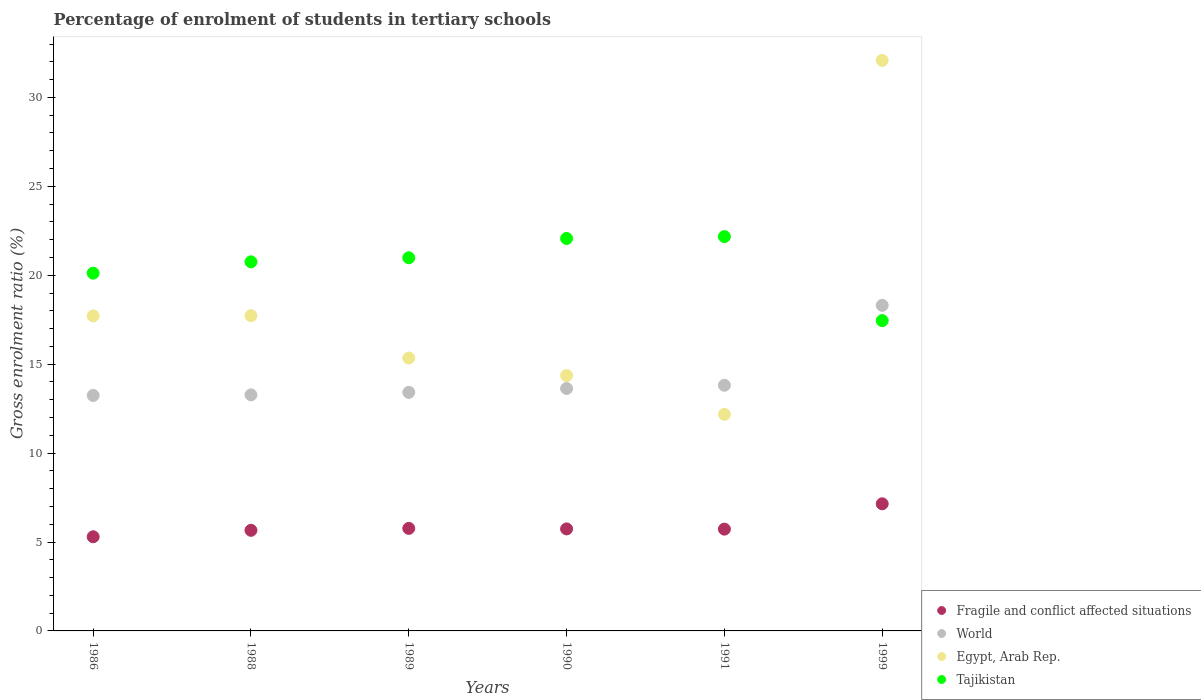How many different coloured dotlines are there?
Your answer should be very brief. 4. What is the percentage of students enrolled in tertiary schools in Tajikistan in 1999?
Your answer should be compact. 17.45. Across all years, what is the maximum percentage of students enrolled in tertiary schools in World?
Your answer should be compact. 18.31. Across all years, what is the minimum percentage of students enrolled in tertiary schools in Egypt, Arab Rep.?
Provide a short and direct response. 12.18. In which year was the percentage of students enrolled in tertiary schools in Tajikistan minimum?
Provide a succinct answer. 1999. What is the total percentage of students enrolled in tertiary schools in Fragile and conflict affected situations in the graph?
Your answer should be very brief. 35.33. What is the difference between the percentage of students enrolled in tertiary schools in Fragile and conflict affected situations in 1989 and that in 1999?
Your answer should be compact. -1.38. What is the difference between the percentage of students enrolled in tertiary schools in Fragile and conflict affected situations in 1988 and the percentage of students enrolled in tertiary schools in Tajikistan in 1999?
Provide a succinct answer. -11.79. What is the average percentage of students enrolled in tertiary schools in Fragile and conflict affected situations per year?
Offer a very short reply. 5.89. In the year 1986, what is the difference between the percentage of students enrolled in tertiary schools in World and percentage of students enrolled in tertiary schools in Egypt, Arab Rep.?
Give a very brief answer. -4.48. What is the ratio of the percentage of students enrolled in tertiary schools in Fragile and conflict affected situations in 1988 to that in 1999?
Keep it short and to the point. 0.79. What is the difference between the highest and the second highest percentage of students enrolled in tertiary schools in Tajikistan?
Provide a succinct answer. 0.11. What is the difference between the highest and the lowest percentage of students enrolled in tertiary schools in Egypt, Arab Rep.?
Make the answer very short. 19.9. In how many years, is the percentage of students enrolled in tertiary schools in Egypt, Arab Rep. greater than the average percentage of students enrolled in tertiary schools in Egypt, Arab Rep. taken over all years?
Your answer should be compact. 1. Is it the case that in every year, the sum of the percentage of students enrolled in tertiary schools in Egypt, Arab Rep. and percentage of students enrolled in tertiary schools in Tajikistan  is greater than the sum of percentage of students enrolled in tertiary schools in World and percentage of students enrolled in tertiary schools in Fragile and conflict affected situations?
Your response must be concise. No. What is the title of the graph?
Provide a short and direct response. Percentage of enrolment of students in tertiary schools. Does "United Arab Emirates" appear as one of the legend labels in the graph?
Give a very brief answer. No. What is the label or title of the X-axis?
Ensure brevity in your answer.  Years. What is the Gross enrolment ratio (%) in Fragile and conflict affected situations in 1986?
Offer a very short reply. 5.29. What is the Gross enrolment ratio (%) of World in 1986?
Provide a short and direct response. 13.24. What is the Gross enrolment ratio (%) of Egypt, Arab Rep. in 1986?
Offer a very short reply. 17.72. What is the Gross enrolment ratio (%) of Tajikistan in 1986?
Provide a succinct answer. 20.12. What is the Gross enrolment ratio (%) in Fragile and conflict affected situations in 1988?
Keep it short and to the point. 5.66. What is the Gross enrolment ratio (%) in World in 1988?
Provide a short and direct response. 13.27. What is the Gross enrolment ratio (%) of Egypt, Arab Rep. in 1988?
Give a very brief answer. 17.73. What is the Gross enrolment ratio (%) of Tajikistan in 1988?
Make the answer very short. 20.75. What is the Gross enrolment ratio (%) in Fragile and conflict affected situations in 1989?
Offer a very short reply. 5.77. What is the Gross enrolment ratio (%) of World in 1989?
Offer a terse response. 13.41. What is the Gross enrolment ratio (%) of Egypt, Arab Rep. in 1989?
Offer a terse response. 15.34. What is the Gross enrolment ratio (%) in Tajikistan in 1989?
Offer a very short reply. 20.98. What is the Gross enrolment ratio (%) in Fragile and conflict affected situations in 1990?
Your answer should be compact. 5.74. What is the Gross enrolment ratio (%) in World in 1990?
Ensure brevity in your answer.  13.63. What is the Gross enrolment ratio (%) of Egypt, Arab Rep. in 1990?
Provide a succinct answer. 14.36. What is the Gross enrolment ratio (%) of Tajikistan in 1990?
Give a very brief answer. 22.07. What is the Gross enrolment ratio (%) of Fragile and conflict affected situations in 1991?
Provide a succinct answer. 5.72. What is the Gross enrolment ratio (%) in World in 1991?
Your answer should be very brief. 13.81. What is the Gross enrolment ratio (%) in Egypt, Arab Rep. in 1991?
Make the answer very short. 12.18. What is the Gross enrolment ratio (%) of Tajikistan in 1991?
Your answer should be compact. 22.17. What is the Gross enrolment ratio (%) in Fragile and conflict affected situations in 1999?
Your answer should be compact. 7.15. What is the Gross enrolment ratio (%) of World in 1999?
Give a very brief answer. 18.31. What is the Gross enrolment ratio (%) of Egypt, Arab Rep. in 1999?
Make the answer very short. 32.08. What is the Gross enrolment ratio (%) of Tajikistan in 1999?
Offer a terse response. 17.45. Across all years, what is the maximum Gross enrolment ratio (%) in Fragile and conflict affected situations?
Offer a very short reply. 7.15. Across all years, what is the maximum Gross enrolment ratio (%) in World?
Provide a short and direct response. 18.31. Across all years, what is the maximum Gross enrolment ratio (%) in Egypt, Arab Rep.?
Make the answer very short. 32.08. Across all years, what is the maximum Gross enrolment ratio (%) in Tajikistan?
Your response must be concise. 22.17. Across all years, what is the minimum Gross enrolment ratio (%) in Fragile and conflict affected situations?
Your answer should be very brief. 5.29. Across all years, what is the minimum Gross enrolment ratio (%) in World?
Keep it short and to the point. 13.24. Across all years, what is the minimum Gross enrolment ratio (%) of Egypt, Arab Rep.?
Make the answer very short. 12.18. Across all years, what is the minimum Gross enrolment ratio (%) of Tajikistan?
Your answer should be compact. 17.45. What is the total Gross enrolment ratio (%) in Fragile and conflict affected situations in the graph?
Provide a short and direct response. 35.33. What is the total Gross enrolment ratio (%) in World in the graph?
Your answer should be compact. 85.68. What is the total Gross enrolment ratio (%) of Egypt, Arab Rep. in the graph?
Ensure brevity in your answer.  109.4. What is the total Gross enrolment ratio (%) in Tajikistan in the graph?
Offer a terse response. 123.54. What is the difference between the Gross enrolment ratio (%) in Fragile and conflict affected situations in 1986 and that in 1988?
Provide a succinct answer. -0.36. What is the difference between the Gross enrolment ratio (%) in World in 1986 and that in 1988?
Provide a short and direct response. -0.03. What is the difference between the Gross enrolment ratio (%) in Egypt, Arab Rep. in 1986 and that in 1988?
Your response must be concise. -0.01. What is the difference between the Gross enrolment ratio (%) in Tajikistan in 1986 and that in 1988?
Provide a succinct answer. -0.64. What is the difference between the Gross enrolment ratio (%) in Fragile and conflict affected situations in 1986 and that in 1989?
Make the answer very short. -0.47. What is the difference between the Gross enrolment ratio (%) of World in 1986 and that in 1989?
Your answer should be compact. -0.17. What is the difference between the Gross enrolment ratio (%) in Egypt, Arab Rep. in 1986 and that in 1989?
Provide a short and direct response. 2.37. What is the difference between the Gross enrolment ratio (%) of Tajikistan in 1986 and that in 1989?
Your response must be concise. -0.87. What is the difference between the Gross enrolment ratio (%) of Fragile and conflict affected situations in 1986 and that in 1990?
Give a very brief answer. -0.44. What is the difference between the Gross enrolment ratio (%) in World in 1986 and that in 1990?
Make the answer very short. -0.39. What is the difference between the Gross enrolment ratio (%) of Egypt, Arab Rep. in 1986 and that in 1990?
Provide a succinct answer. 3.36. What is the difference between the Gross enrolment ratio (%) of Tajikistan in 1986 and that in 1990?
Offer a terse response. -1.95. What is the difference between the Gross enrolment ratio (%) in Fragile and conflict affected situations in 1986 and that in 1991?
Keep it short and to the point. -0.43. What is the difference between the Gross enrolment ratio (%) of World in 1986 and that in 1991?
Ensure brevity in your answer.  -0.57. What is the difference between the Gross enrolment ratio (%) of Egypt, Arab Rep. in 1986 and that in 1991?
Your answer should be very brief. 5.54. What is the difference between the Gross enrolment ratio (%) in Tajikistan in 1986 and that in 1991?
Provide a succinct answer. -2.05. What is the difference between the Gross enrolment ratio (%) of Fragile and conflict affected situations in 1986 and that in 1999?
Provide a succinct answer. -1.85. What is the difference between the Gross enrolment ratio (%) of World in 1986 and that in 1999?
Keep it short and to the point. -5.07. What is the difference between the Gross enrolment ratio (%) in Egypt, Arab Rep. in 1986 and that in 1999?
Offer a very short reply. -14.37. What is the difference between the Gross enrolment ratio (%) of Tajikistan in 1986 and that in 1999?
Make the answer very short. 2.67. What is the difference between the Gross enrolment ratio (%) in Fragile and conflict affected situations in 1988 and that in 1989?
Offer a very short reply. -0.11. What is the difference between the Gross enrolment ratio (%) of World in 1988 and that in 1989?
Offer a very short reply. -0.14. What is the difference between the Gross enrolment ratio (%) in Egypt, Arab Rep. in 1988 and that in 1989?
Offer a very short reply. 2.38. What is the difference between the Gross enrolment ratio (%) of Tajikistan in 1988 and that in 1989?
Provide a short and direct response. -0.23. What is the difference between the Gross enrolment ratio (%) in Fragile and conflict affected situations in 1988 and that in 1990?
Give a very brief answer. -0.08. What is the difference between the Gross enrolment ratio (%) of World in 1988 and that in 1990?
Your response must be concise. -0.36. What is the difference between the Gross enrolment ratio (%) in Egypt, Arab Rep. in 1988 and that in 1990?
Ensure brevity in your answer.  3.37. What is the difference between the Gross enrolment ratio (%) of Tajikistan in 1988 and that in 1990?
Ensure brevity in your answer.  -1.31. What is the difference between the Gross enrolment ratio (%) of Fragile and conflict affected situations in 1988 and that in 1991?
Your answer should be very brief. -0.07. What is the difference between the Gross enrolment ratio (%) in World in 1988 and that in 1991?
Keep it short and to the point. -0.54. What is the difference between the Gross enrolment ratio (%) of Egypt, Arab Rep. in 1988 and that in 1991?
Provide a short and direct response. 5.55. What is the difference between the Gross enrolment ratio (%) in Tajikistan in 1988 and that in 1991?
Ensure brevity in your answer.  -1.42. What is the difference between the Gross enrolment ratio (%) of Fragile and conflict affected situations in 1988 and that in 1999?
Give a very brief answer. -1.49. What is the difference between the Gross enrolment ratio (%) of World in 1988 and that in 1999?
Make the answer very short. -5.03. What is the difference between the Gross enrolment ratio (%) of Egypt, Arab Rep. in 1988 and that in 1999?
Provide a short and direct response. -14.36. What is the difference between the Gross enrolment ratio (%) of Tajikistan in 1988 and that in 1999?
Your answer should be compact. 3.31. What is the difference between the Gross enrolment ratio (%) of Fragile and conflict affected situations in 1989 and that in 1990?
Give a very brief answer. 0.03. What is the difference between the Gross enrolment ratio (%) in World in 1989 and that in 1990?
Your answer should be compact. -0.22. What is the difference between the Gross enrolment ratio (%) of Tajikistan in 1989 and that in 1990?
Your response must be concise. -1.08. What is the difference between the Gross enrolment ratio (%) of Fragile and conflict affected situations in 1989 and that in 1991?
Make the answer very short. 0.04. What is the difference between the Gross enrolment ratio (%) of World in 1989 and that in 1991?
Keep it short and to the point. -0.4. What is the difference between the Gross enrolment ratio (%) in Egypt, Arab Rep. in 1989 and that in 1991?
Provide a short and direct response. 3.17. What is the difference between the Gross enrolment ratio (%) in Tajikistan in 1989 and that in 1991?
Make the answer very short. -1.19. What is the difference between the Gross enrolment ratio (%) of Fragile and conflict affected situations in 1989 and that in 1999?
Provide a succinct answer. -1.38. What is the difference between the Gross enrolment ratio (%) in World in 1989 and that in 1999?
Your answer should be very brief. -4.89. What is the difference between the Gross enrolment ratio (%) in Egypt, Arab Rep. in 1989 and that in 1999?
Keep it short and to the point. -16.74. What is the difference between the Gross enrolment ratio (%) in Tajikistan in 1989 and that in 1999?
Provide a succinct answer. 3.53. What is the difference between the Gross enrolment ratio (%) in Fragile and conflict affected situations in 1990 and that in 1991?
Your response must be concise. 0.01. What is the difference between the Gross enrolment ratio (%) in World in 1990 and that in 1991?
Provide a succinct answer. -0.18. What is the difference between the Gross enrolment ratio (%) of Egypt, Arab Rep. in 1990 and that in 1991?
Your response must be concise. 2.18. What is the difference between the Gross enrolment ratio (%) of Tajikistan in 1990 and that in 1991?
Ensure brevity in your answer.  -0.11. What is the difference between the Gross enrolment ratio (%) of Fragile and conflict affected situations in 1990 and that in 1999?
Keep it short and to the point. -1.41. What is the difference between the Gross enrolment ratio (%) in World in 1990 and that in 1999?
Offer a terse response. -4.68. What is the difference between the Gross enrolment ratio (%) of Egypt, Arab Rep. in 1990 and that in 1999?
Make the answer very short. -17.72. What is the difference between the Gross enrolment ratio (%) of Tajikistan in 1990 and that in 1999?
Your answer should be very brief. 4.62. What is the difference between the Gross enrolment ratio (%) in Fragile and conflict affected situations in 1991 and that in 1999?
Keep it short and to the point. -1.42. What is the difference between the Gross enrolment ratio (%) in World in 1991 and that in 1999?
Make the answer very short. -4.49. What is the difference between the Gross enrolment ratio (%) in Egypt, Arab Rep. in 1991 and that in 1999?
Offer a very short reply. -19.9. What is the difference between the Gross enrolment ratio (%) in Tajikistan in 1991 and that in 1999?
Give a very brief answer. 4.72. What is the difference between the Gross enrolment ratio (%) in Fragile and conflict affected situations in 1986 and the Gross enrolment ratio (%) in World in 1988?
Your answer should be compact. -7.98. What is the difference between the Gross enrolment ratio (%) of Fragile and conflict affected situations in 1986 and the Gross enrolment ratio (%) of Egypt, Arab Rep. in 1988?
Offer a terse response. -12.43. What is the difference between the Gross enrolment ratio (%) in Fragile and conflict affected situations in 1986 and the Gross enrolment ratio (%) in Tajikistan in 1988?
Make the answer very short. -15.46. What is the difference between the Gross enrolment ratio (%) of World in 1986 and the Gross enrolment ratio (%) of Egypt, Arab Rep. in 1988?
Keep it short and to the point. -4.49. What is the difference between the Gross enrolment ratio (%) in World in 1986 and the Gross enrolment ratio (%) in Tajikistan in 1988?
Give a very brief answer. -7.51. What is the difference between the Gross enrolment ratio (%) of Egypt, Arab Rep. in 1986 and the Gross enrolment ratio (%) of Tajikistan in 1988?
Give a very brief answer. -3.04. What is the difference between the Gross enrolment ratio (%) of Fragile and conflict affected situations in 1986 and the Gross enrolment ratio (%) of World in 1989?
Ensure brevity in your answer.  -8.12. What is the difference between the Gross enrolment ratio (%) in Fragile and conflict affected situations in 1986 and the Gross enrolment ratio (%) in Egypt, Arab Rep. in 1989?
Your answer should be very brief. -10.05. What is the difference between the Gross enrolment ratio (%) in Fragile and conflict affected situations in 1986 and the Gross enrolment ratio (%) in Tajikistan in 1989?
Provide a short and direct response. -15.69. What is the difference between the Gross enrolment ratio (%) in World in 1986 and the Gross enrolment ratio (%) in Egypt, Arab Rep. in 1989?
Offer a very short reply. -2.1. What is the difference between the Gross enrolment ratio (%) of World in 1986 and the Gross enrolment ratio (%) of Tajikistan in 1989?
Your answer should be very brief. -7.74. What is the difference between the Gross enrolment ratio (%) of Egypt, Arab Rep. in 1986 and the Gross enrolment ratio (%) of Tajikistan in 1989?
Your answer should be very brief. -3.27. What is the difference between the Gross enrolment ratio (%) in Fragile and conflict affected situations in 1986 and the Gross enrolment ratio (%) in World in 1990?
Offer a terse response. -8.34. What is the difference between the Gross enrolment ratio (%) in Fragile and conflict affected situations in 1986 and the Gross enrolment ratio (%) in Egypt, Arab Rep. in 1990?
Your answer should be compact. -9.06. What is the difference between the Gross enrolment ratio (%) in Fragile and conflict affected situations in 1986 and the Gross enrolment ratio (%) in Tajikistan in 1990?
Your response must be concise. -16.77. What is the difference between the Gross enrolment ratio (%) of World in 1986 and the Gross enrolment ratio (%) of Egypt, Arab Rep. in 1990?
Your answer should be very brief. -1.12. What is the difference between the Gross enrolment ratio (%) in World in 1986 and the Gross enrolment ratio (%) in Tajikistan in 1990?
Make the answer very short. -8.83. What is the difference between the Gross enrolment ratio (%) of Egypt, Arab Rep. in 1986 and the Gross enrolment ratio (%) of Tajikistan in 1990?
Provide a succinct answer. -4.35. What is the difference between the Gross enrolment ratio (%) in Fragile and conflict affected situations in 1986 and the Gross enrolment ratio (%) in World in 1991?
Give a very brief answer. -8.52. What is the difference between the Gross enrolment ratio (%) of Fragile and conflict affected situations in 1986 and the Gross enrolment ratio (%) of Egypt, Arab Rep. in 1991?
Ensure brevity in your answer.  -6.88. What is the difference between the Gross enrolment ratio (%) of Fragile and conflict affected situations in 1986 and the Gross enrolment ratio (%) of Tajikistan in 1991?
Offer a very short reply. -16.88. What is the difference between the Gross enrolment ratio (%) of World in 1986 and the Gross enrolment ratio (%) of Egypt, Arab Rep. in 1991?
Offer a terse response. 1.06. What is the difference between the Gross enrolment ratio (%) of World in 1986 and the Gross enrolment ratio (%) of Tajikistan in 1991?
Provide a short and direct response. -8.93. What is the difference between the Gross enrolment ratio (%) in Egypt, Arab Rep. in 1986 and the Gross enrolment ratio (%) in Tajikistan in 1991?
Offer a very short reply. -4.46. What is the difference between the Gross enrolment ratio (%) in Fragile and conflict affected situations in 1986 and the Gross enrolment ratio (%) in World in 1999?
Make the answer very short. -13.01. What is the difference between the Gross enrolment ratio (%) of Fragile and conflict affected situations in 1986 and the Gross enrolment ratio (%) of Egypt, Arab Rep. in 1999?
Ensure brevity in your answer.  -26.79. What is the difference between the Gross enrolment ratio (%) in Fragile and conflict affected situations in 1986 and the Gross enrolment ratio (%) in Tajikistan in 1999?
Provide a succinct answer. -12.15. What is the difference between the Gross enrolment ratio (%) in World in 1986 and the Gross enrolment ratio (%) in Egypt, Arab Rep. in 1999?
Offer a very short reply. -18.84. What is the difference between the Gross enrolment ratio (%) of World in 1986 and the Gross enrolment ratio (%) of Tajikistan in 1999?
Offer a terse response. -4.21. What is the difference between the Gross enrolment ratio (%) in Egypt, Arab Rep. in 1986 and the Gross enrolment ratio (%) in Tajikistan in 1999?
Keep it short and to the point. 0.27. What is the difference between the Gross enrolment ratio (%) of Fragile and conflict affected situations in 1988 and the Gross enrolment ratio (%) of World in 1989?
Make the answer very short. -7.76. What is the difference between the Gross enrolment ratio (%) of Fragile and conflict affected situations in 1988 and the Gross enrolment ratio (%) of Egypt, Arab Rep. in 1989?
Ensure brevity in your answer.  -9.69. What is the difference between the Gross enrolment ratio (%) of Fragile and conflict affected situations in 1988 and the Gross enrolment ratio (%) of Tajikistan in 1989?
Offer a very short reply. -15.33. What is the difference between the Gross enrolment ratio (%) in World in 1988 and the Gross enrolment ratio (%) in Egypt, Arab Rep. in 1989?
Offer a terse response. -2.07. What is the difference between the Gross enrolment ratio (%) in World in 1988 and the Gross enrolment ratio (%) in Tajikistan in 1989?
Make the answer very short. -7.71. What is the difference between the Gross enrolment ratio (%) of Egypt, Arab Rep. in 1988 and the Gross enrolment ratio (%) of Tajikistan in 1989?
Your response must be concise. -3.26. What is the difference between the Gross enrolment ratio (%) of Fragile and conflict affected situations in 1988 and the Gross enrolment ratio (%) of World in 1990?
Offer a terse response. -7.97. What is the difference between the Gross enrolment ratio (%) in Fragile and conflict affected situations in 1988 and the Gross enrolment ratio (%) in Egypt, Arab Rep. in 1990?
Your response must be concise. -8.7. What is the difference between the Gross enrolment ratio (%) of Fragile and conflict affected situations in 1988 and the Gross enrolment ratio (%) of Tajikistan in 1990?
Provide a short and direct response. -16.41. What is the difference between the Gross enrolment ratio (%) of World in 1988 and the Gross enrolment ratio (%) of Egypt, Arab Rep. in 1990?
Provide a succinct answer. -1.09. What is the difference between the Gross enrolment ratio (%) in World in 1988 and the Gross enrolment ratio (%) in Tajikistan in 1990?
Your response must be concise. -8.79. What is the difference between the Gross enrolment ratio (%) in Egypt, Arab Rep. in 1988 and the Gross enrolment ratio (%) in Tajikistan in 1990?
Your answer should be very brief. -4.34. What is the difference between the Gross enrolment ratio (%) in Fragile and conflict affected situations in 1988 and the Gross enrolment ratio (%) in World in 1991?
Give a very brief answer. -8.16. What is the difference between the Gross enrolment ratio (%) in Fragile and conflict affected situations in 1988 and the Gross enrolment ratio (%) in Egypt, Arab Rep. in 1991?
Your answer should be very brief. -6.52. What is the difference between the Gross enrolment ratio (%) in Fragile and conflict affected situations in 1988 and the Gross enrolment ratio (%) in Tajikistan in 1991?
Ensure brevity in your answer.  -16.51. What is the difference between the Gross enrolment ratio (%) of World in 1988 and the Gross enrolment ratio (%) of Egypt, Arab Rep. in 1991?
Your answer should be very brief. 1.1. What is the difference between the Gross enrolment ratio (%) of World in 1988 and the Gross enrolment ratio (%) of Tajikistan in 1991?
Ensure brevity in your answer.  -8.9. What is the difference between the Gross enrolment ratio (%) of Egypt, Arab Rep. in 1988 and the Gross enrolment ratio (%) of Tajikistan in 1991?
Make the answer very short. -4.45. What is the difference between the Gross enrolment ratio (%) in Fragile and conflict affected situations in 1988 and the Gross enrolment ratio (%) in World in 1999?
Your answer should be compact. -12.65. What is the difference between the Gross enrolment ratio (%) in Fragile and conflict affected situations in 1988 and the Gross enrolment ratio (%) in Egypt, Arab Rep. in 1999?
Make the answer very short. -26.42. What is the difference between the Gross enrolment ratio (%) of Fragile and conflict affected situations in 1988 and the Gross enrolment ratio (%) of Tajikistan in 1999?
Provide a short and direct response. -11.79. What is the difference between the Gross enrolment ratio (%) of World in 1988 and the Gross enrolment ratio (%) of Egypt, Arab Rep. in 1999?
Offer a terse response. -18.81. What is the difference between the Gross enrolment ratio (%) of World in 1988 and the Gross enrolment ratio (%) of Tajikistan in 1999?
Provide a short and direct response. -4.17. What is the difference between the Gross enrolment ratio (%) of Egypt, Arab Rep. in 1988 and the Gross enrolment ratio (%) of Tajikistan in 1999?
Provide a succinct answer. 0.28. What is the difference between the Gross enrolment ratio (%) in Fragile and conflict affected situations in 1989 and the Gross enrolment ratio (%) in World in 1990?
Keep it short and to the point. -7.87. What is the difference between the Gross enrolment ratio (%) in Fragile and conflict affected situations in 1989 and the Gross enrolment ratio (%) in Egypt, Arab Rep. in 1990?
Keep it short and to the point. -8.59. What is the difference between the Gross enrolment ratio (%) in Fragile and conflict affected situations in 1989 and the Gross enrolment ratio (%) in Tajikistan in 1990?
Your answer should be very brief. -16.3. What is the difference between the Gross enrolment ratio (%) of World in 1989 and the Gross enrolment ratio (%) of Egypt, Arab Rep. in 1990?
Offer a very short reply. -0.95. What is the difference between the Gross enrolment ratio (%) in World in 1989 and the Gross enrolment ratio (%) in Tajikistan in 1990?
Offer a very short reply. -8.65. What is the difference between the Gross enrolment ratio (%) in Egypt, Arab Rep. in 1989 and the Gross enrolment ratio (%) in Tajikistan in 1990?
Provide a succinct answer. -6.72. What is the difference between the Gross enrolment ratio (%) of Fragile and conflict affected situations in 1989 and the Gross enrolment ratio (%) of World in 1991?
Your answer should be compact. -8.05. What is the difference between the Gross enrolment ratio (%) of Fragile and conflict affected situations in 1989 and the Gross enrolment ratio (%) of Egypt, Arab Rep. in 1991?
Make the answer very short. -6.41. What is the difference between the Gross enrolment ratio (%) of Fragile and conflict affected situations in 1989 and the Gross enrolment ratio (%) of Tajikistan in 1991?
Give a very brief answer. -16.41. What is the difference between the Gross enrolment ratio (%) in World in 1989 and the Gross enrolment ratio (%) in Egypt, Arab Rep. in 1991?
Provide a short and direct response. 1.24. What is the difference between the Gross enrolment ratio (%) of World in 1989 and the Gross enrolment ratio (%) of Tajikistan in 1991?
Your answer should be very brief. -8.76. What is the difference between the Gross enrolment ratio (%) of Egypt, Arab Rep. in 1989 and the Gross enrolment ratio (%) of Tajikistan in 1991?
Offer a very short reply. -6.83. What is the difference between the Gross enrolment ratio (%) in Fragile and conflict affected situations in 1989 and the Gross enrolment ratio (%) in World in 1999?
Your response must be concise. -12.54. What is the difference between the Gross enrolment ratio (%) in Fragile and conflict affected situations in 1989 and the Gross enrolment ratio (%) in Egypt, Arab Rep. in 1999?
Provide a short and direct response. -26.32. What is the difference between the Gross enrolment ratio (%) in Fragile and conflict affected situations in 1989 and the Gross enrolment ratio (%) in Tajikistan in 1999?
Offer a terse response. -11.68. What is the difference between the Gross enrolment ratio (%) in World in 1989 and the Gross enrolment ratio (%) in Egypt, Arab Rep. in 1999?
Keep it short and to the point. -18.67. What is the difference between the Gross enrolment ratio (%) in World in 1989 and the Gross enrolment ratio (%) in Tajikistan in 1999?
Ensure brevity in your answer.  -4.03. What is the difference between the Gross enrolment ratio (%) of Egypt, Arab Rep. in 1989 and the Gross enrolment ratio (%) of Tajikistan in 1999?
Give a very brief answer. -2.11. What is the difference between the Gross enrolment ratio (%) of Fragile and conflict affected situations in 1990 and the Gross enrolment ratio (%) of World in 1991?
Make the answer very short. -8.08. What is the difference between the Gross enrolment ratio (%) of Fragile and conflict affected situations in 1990 and the Gross enrolment ratio (%) of Egypt, Arab Rep. in 1991?
Provide a succinct answer. -6.44. What is the difference between the Gross enrolment ratio (%) of Fragile and conflict affected situations in 1990 and the Gross enrolment ratio (%) of Tajikistan in 1991?
Give a very brief answer. -16.44. What is the difference between the Gross enrolment ratio (%) in World in 1990 and the Gross enrolment ratio (%) in Egypt, Arab Rep. in 1991?
Keep it short and to the point. 1.45. What is the difference between the Gross enrolment ratio (%) of World in 1990 and the Gross enrolment ratio (%) of Tajikistan in 1991?
Make the answer very short. -8.54. What is the difference between the Gross enrolment ratio (%) of Egypt, Arab Rep. in 1990 and the Gross enrolment ratio (%) of Tajikistan in 1991?
Provide a short and direct response. -7.81. What is the difference between the Gross enrolment ratio (%) in Fragile and conflict affected situations in 1990 and the Gross enrolment ratio (%) in World in 1999?
Offer a very short reply. -12.57. What is the difference between the Gross enrolment ratio (%) of Fragile and conflict affected situations in 1990 and the Gross enrolment ratio (%) of Egypt, Arab Rep. in 1999?
Provide a short and direct response. -26.34. What is the difference between the Gross enrolment ratio (%) of Fragile and conflict affected situations in 1990 and the Gross enrolment ratio (%) of Tajikistan in 1999?
Provide a short and direct response. -11.71. What is the difference between the Gross enrolment ratio (%) of World in 1990 and the Gross enrolment ratio (%) of Egypt, Arab Rep. in 1999?
Your answer should be very brief. -18.45. What is the difference between the Gross enrolment ratio (%) in World in 1990 and the Gross enrolment ratio (%) in Tajikistan in 1999?
Your response must be concise. -3.82. What is the difference between the Gross enrolment ratio (%) in Egypt, Arab Rep. in 1990 and the Gross enrolment ratio (%) in Tajikistan in 1999?
Your answer should be very brief. -3.09. What is the difference between the Gross enrolment ratio (%) in Fragile and conflict affected situations in 1991 and the Gross enrolment ratio (%) in World in 1999?
Your answer should be very brief. -12.58. What is the difference between the Gross enrolment ratio (%) of Fragile and conflict affected situations in 1991 and the Gross enrolment ratio (%) of Egypt, Arab Rep. in 1999?
Ensure brevity in your answer.  -26.36. What is the difference between the Gross enrolment ratio (%) of Fragile and conflict affected situations in 1991 and the Gross enrolment ratio (%) of Tajikistan in 1999?
Offer a terse response. -11.72. What is the difference between the Gross enrolment ratio (%) in World in 1991 and the Gross enrolment ratio (%) in Egypt, Arab Rep. in 1999?
Your response must be concise. -18.27. What is the difference between the Gross enrolment ratio (%) of World in 1991 and the Gross enrolment ratio (%) of Tajikistan in 1999?
Give a very brief answer. -3.64. What is the difference between the Gross enrolment ratio (%) of Egypt, Arab Rep. in 1991 and the Gross enrolment ratio (%) of Tajikistan in 1999?
Your answer should be very brief. -5.27. What is the average Gross enrolment ratio (%) in Fragile and conflict affected situations per year?
Make the answer very short. 5.89. What is the average Gross enrolment ratio (%) in World per year?
Offer a very short reply. 14.28. What is the average Gross enrolment ratio (%) in Egypt, Arab Rep. per year?
Provide a succinct answer. 18.23. What is the average Gross enrolment ratio (%) of Tajikistan per year?
Your response must be concise. 20.59. In the year 1986, what is the difference between the Gross enrolment ratio (%) in Fragile and conflict affected situations and Gross enrolment ratio (%) in World?
Offer a terse response. -7.95. In the year 1986, what is the difference between the Gross enrolment ratio (%) in Fragile and conflict affected situations and Gross enrolment ratio (%) in Egypt, Arab Rep.?
Offer a terse response. -12.42. In the year 1986, what is the difference between the Gross enrolment ratio (%) in Fragile and conflict affected situations and Gross enrolment ratio (%) in Tajikistan?
Give a very brief answer. -14.82. In the year 1986, what is the difference between the Gross enrolment ratio (%) of World and Gross enrolment ratio (%) of Egypt, Arab Rep.?
Your answer should be compact. -4.48. In the year 1986, what is the difference between the Gross enrolment ratio (%) in World and Gross enrolment ratio (%) in Tajikistan?
Offer a terse response. -6.88. In the year 1986, what is the difference between the Gross enrolment ratio (%) of Egypt, Arab Rep. and Gross enrolment ratio (%) of Tajikistan?
Your answer should be very brief. -2.4. In the year 1988, what is the difference between the Gross enrolment ratio (%) of Fragile and conflict affected situations and Gross enrolment ratio (%) of World?
Provide a succinct answer. -7.62. In the year 1988, what is the difference between the Gross enrolment ratio (%) of Fragile and conflict affected situations and Gross enrolment ratio (%) of Egypt, Arab Rep.?
Give a very brief answer. -12.07. In the year 1988, what is the difference between the Gross enrolment ratio (%) of Fragile and conflict affected situations and Gross enrolment ratio (%) of Tajikistan?
Make the answer very short. -15.1. In the year 1988, what is the difference between the Gross enrolment ratio (%) in World and Gross enrolment ratio (%) in Egypt, Arab Rep.?
Ensure brevity in your answer.  -4.45. In the year 1988, what is the difference between the Gross enrolment ratio (%) of World and Gross enrolment ratio (%) of Tajikistan?
Provide a short and direct response. -7.48. In the year 1988, what is the difference between the Gross enrolment ratio (%) in Egypt, Arab Rep. and Gross enrolment ratio (%) in Tajikistan?
Your answer should be very brief. -3.03. In the year 1989, what is the difference between the Gross enrolment ratio (%) of Fragile and conflict affected situations and Gross enrolment ratio (%) of World?
Keep it short and to the point. -7.65. In the year 1989, what is the difference between the Gross enrolment ratio (%) of Fragile and conflict affected situations and Gross enrolment ratio (%) of Egypt, Arab Rep.?
Your answer should be very brief. -9.58. In the year 1989, what is the difference between the Gross enrolment ratio (%) of Fragile and conflict affected situations and Gross enrolment ratio (%) of Tajikistan?
Your answer should be compact. -15.22. In the year 1989, what is the difference between the Gross enrolment ratio (%) of World and Gross enrolment ratio (%) of Egypt, Arab Rep.?
Offer a very short reply. -1.93. In the year 1989, what is the difference between the Gross enrolment ratio (%) in World and Gross enrolment ratio (%) in Tajikistan?
Your response must be concise. -7.57. In the year 1989, what is the difference between the Gross enrolment ratio (%) of Egypt, Arab Rep. and Gross enrolment ratio (%) of Tajikistan?
Your answer should be very brief. -5.64. In the year 1990, what is the difference between the Gross enrolment ratio (%) in Fragile and conflict affected situations and Gross enrolment ratio (%) in World?
Your answer should be compact. -7.89. In the year 1990, what is the difference between the Gross enrolment ratio (%) of Fragile and conflict affected situations and Gross enrolment ratio (%) of Egypt, Arab Rep.?
Provide a short and direct response. -8.62. In the year 1990, what is the difference between the Gross enrolment ratio (%) in Fragile and conflict affected situations and Gross enrolment ratio (%) in Tajikistan?
Give a very brief answer. -16.33. In the year 1990, what is the difference between the Gross enrolment ratio (%) in World and Gross enrolment ratio (%) in Egypt, Arab Rep.?
Ensure brevity in your answer.  -0.73. In the year 1990, what is the difference between the Gross enrolment ratio (%) of World and Gross enrolment ratio (%) of Tajikistan?
Offer a very short reply. -8.44. In the year 1990, what is the difference between the Gross enrolment ratio (%) of Egypt, Arab Rep. and Gross enrolment ratio (%) of Tajikistan?
Offer a terse response. -7.71. In the year 1991, what is the difference between the Gross enrolment ratio (%) of Fragile and conflict affected situations and Gross enrolment ratio (%) of World?
Provide a succinct answer. -8.09. In the year 1991, what is the difference between the Gross enrolment ratio (%) in Fragile and conflict affected situations and Gross enrolment ratio (%) in Egypt, Arab Rep.?
Keep it short and to the point. -6.45. In the year 1991, what is the difference between the Gross enrolment ratio (%) in Fragile and conflict affected situations and Gross enrolment ratio (%) in Tajikistan?
Give a very brief answer. -16.45. In the year 1991, what is the difference between the Gross enrolment ratio (%) in World and Gross enrolment ratio (%) in Egypt, Arab Rep.?
Your response must be concise. 1.63. In the year 1991, what is the difference between the Gross enrolment ratio (%) in World and Gross enrolment ratio (%) in Tajikistan?
Your answer should be compact. -8.36. In the year 1991, what is the difference between the Gross enrolment ratio (%) of Egypt, Arab Rep. and Gross enrolment ratio (%) of Tajikistan?
Offer a very short reply. -9.99. In the year 1999, what is the difference between the Gross enrolment ratio (%) of Fragile and conflict affected situations and Gross enrolment ratio (%) of World?
Offer a very short reply. -11.16. In the year 1999, what is the difference between the Gross enrolment ratio (%) of Fragile and conflict affected situations and Gross enrolment ratio (%) of Egypt, Arab Rep.?
Give a very brief answer. -24.93. In the year 1999, what is the difference between the Gross enrolment ratio (%) of Fragile and conflict affected situations and Gross enrolment ratio (%) of Tajikistan?
Your answer should be compact. -10.3. In the year 1999, what is the difference between the Gross enrolment ratio (%) in World and Gross enrolment ratio (%) in Egypt, Arab Rep.?
Your answer should be compact. -13.77. In the year 1999, what is the difference between the Gross enrolment ratio (%) of World and Gross enrolment ratio (%) of Tajikistan?
Offer a very short reply. 0.86. In the year 1999, what is the difference between the Gross enrolment ratio (%) of Egypt, Arab Rep. and Gross enrolment ratio (%) of Tajikistan?
Ensure brevity in your answer.  14.63. What is the ratio of the Gross enrolment ratio (%) in Fragile and conflict affected situations in 1986 to that in 1988?
Provide a succinct answer. 0.94. What is the ratio of the Gross enrolment ratio (%) of Egypt, Arab Rep. in 1986 to that in 1988?
Provide a short and direct response. 1. What is the ratio of the Gross enrolment ratio (%) in Tajikistan in 1986 to that in 1988?
Ensure brevity in your answer.  0.97. What is the ratio of the Gross enrolment ratio (%) of Fragile and conflict affected situations in 1986 to that in 1989?
Make the answer very short. 0.92. What is the ratio of the Gross enrolment ratio (%) of Egypt, Arab Rep. in 1986 to that in 1989?
Give a very brief answer. 1.15. What is the ratio of the Gross enrolment ratio (%) in Tajikistan in 1986 to that in 1989?
Provide a short and direct response. 0.96. What is the ratio of the Gross enrolment ratio (%) in Fragile and conflict affected situations in 1986 to that in 1990?
Offer a terse response. 0.92. What is the ratio of the Gross enrolment ratio (%) in World in 1986 to that in 1990?
Offer a terse response. 0.97. What is the ratio of the Gross enrolment ratio (%) of Egypt, Arab Rep. in 1986 to that in 1990?
Offer a very short reply. 1.23. What is the ratio of the Gross enrolment ratio (%) of Tajikistan in 1986 to that in 1990?
Provide a short and direct response. 0.91. What is the ratio of the Gross enrolment ratio (%) in Fragile and conflict affected situations in 1986 to that in 1991?
Provide a succinct answer. 0.93. What is the ratio of the Gross enrolment ratio (%) of World in 1986 to that in 1991?
Give a very brief answer. 0.96. What is the ratio of the Gross enrolment ratio (%) in Egypt, Arab Rep. in 1986 to that in 1991?
Keep it short and to the point. 1.45. What is the ratio of the Gross enrolment ratio (%) in Tajikistan in 1986 to that in 1991?
Provide a succinct answer. 0.91. What is the ratio of the Gross enrolment ratio (%) in Fragile and conflict affected situations in 1986 to that in 1999?
Provide a short and direct response. 0.74. What is the ratio of the Gross enrolment ratio (%) of World in 1986 to that in 1999?
Provide a succinct answer. 0.72. What is the ratio of the Gross enrolment ratio (%) in Egypt, Arab Rep. in 1986 to that in 1999?
Offer a very short reply. 0.55. What is the ratio of the Gross enrolment ratio (%) of Tajikistan in 1986 to that in 1999?
Make the answer very short. 1.15. What is the ratio of the Gross enrolment ratio (%) in Fragile and conflict affected situations in 1988 to that in 1989?
Your answer should be very brief. 0.98. What is the ratio of the Gross enrolment ratio (%) in Egypt, Arab Rep. in 1988 to that in 1989?
Provide a succinct answer. 1.16. What is the ratio of the Gross enrolment ratio (%) in Fragile and conflict affected situations in 1988 to that in 1990?
Your answer should be compact. 0.99. What is the ratio of the Gross enrolment ratio (%) of World in 1988 to that in 1990?
Ensure brevity in your answer.  0.97. What is the ratio of the Gross enrolment ratio (%) in Egypt, Arab Rep. in 1988 to that in 1990?
Offer a terse response. 1.23. What is the ratio of the Gross enrolment ratio (%) of Tajikistan in 1988 to that in 1990?
Your answer should be compact. 0.94. What is the ratio of the Gross enrolment ratio (%) of Fragile and conflict affected situations in 1988 to that in 1991?
Provide a short and direct response. 0.99. What is the ratio of the Gross enrolment ratio (%) in Egypt, Arab Rep. in 1988 to that in 1991?
Provide a short and direct response. 1.46. What is the ratio of the Gross enrolment ratio (%) in Tajikistan in 1988 to that in 1991?
Your response must be concise. 0.94. What is the ratio of the Gross enrolment ratio (%) in Fragile and conflict affected situations in 1988 to that in 1999?
Make the answer very short. 0.79. What is the ratio of the Gross enrolment ratio (%) in World in 1988 to that in 1999?
Your response must be concise. 0.73. What is the ratio of the Gross enrolment ratio (%) of Egypt, Arab Rep. in 1988 to that in 1999?
Your response must be concise. 0.55. What is the ratio of the Gross enrolment ratio (%) in Tajikistan in 1988 to that in 1999?
Your answer should be very brief. 1.19. What is the ratio of the Gross enrolment ratio (%) of Fragile and conflict affected situations in 1989 to that in 1990?
Your answer should be very brief. 1.01. What is the ratio of the Gross enrolment ratio (%) of World in 1989 to that in 1990?
Your answer should be very brief. 0.98. What is the ratio of the Gross enrolment ratio (%) in Egypt, Arab Rep. in 1989 to that in 1990?
Offer a terse response. 1.07. What is the ratio of the Gross enrolment ratio (%) of Tajikistan in 1989 to that in 1990?
Provide a succinct answer. 0.95. What is the ratio of the Gross enrolment ratio (%) in Fragile and conflict affected situations in 1989 to that in 1991?
Keep it short and to the point. 1.01. What is the ratio of the Gross enrolment ratio (%) of World in 1989 to that in 1991?
Offer a very short reply. 0.97. What is the ratio of the Gross enrolment ratio (%) in Egypt, Arab Rep. in 1989 to that in 1991?
Provide a short and direct response. 1.26. What is the ratio of the Gross enrolment ratio (%) in Tajikistan in 1989 to that in 1991?
Keep it short and to the point. 0.95. What is the ratio of the Gross enrolment ratio (%) of Fragile and conflict affected situations in 1989 to that in 1999?
Your answer should be very brief. 0.81. What is the ratio of the Gross enrolment ratio (%) of World in 1989 to that in 1999?
Provide a short and direct response. 0.73. What is the ratio of the Gross enrolment ratio (%) in Egypt, Arab Rep. in 1989 to that in 1999?
Provide a short and direct response. 0.48. What is the ratio of the Gross enrolment ratio (%) of Tajikistan in 1989 to that in 1999?
Your answer should be very brief. 1.2. What is the ratio of the Gross enrolment ratio (%) of Fragile and conflict affected situations in 1990 to that in 1991?
Make the answer very short. 1. What is the ratio of the Gross enrolment ratio (%) in Egypt, Arab Rep. in 1990 to that in 1991?
Offer a terse response. 1.18. What is the ratio of the Gross enrolment ratio (%) in Fragile and conflict affected situations in 1990 to that in 1999?
Offer a very short reply. 0.8. What is the ratio of the Gross enrolment ratio (%) of World in 1990 to that in 1999?
Your answer should be very brief. 0.74. What is the ratio of the Gross enrolment ratio (%) of Egypt, Arab Rep. in 1990 to that in 1999?
Keep it short and to the point. 0.45. What is the ratio of the Gross enrolment ratio (%) of Tajikistan in 1990 to that in 1999?
Keep it short and to the point. 1.26. What is the ratio of the Gross enrolment ratio (%) of Fragile and conflict affected situations in 1991 to that in 1999?
Make the answer very short. 0.8. What is the ratio of the Gross enrolment ratio (%) of World in 1991 to that in 1999?
Your answer should be compact. 0.75. What is the ratio of the Gross enrolment ratio (%) in Egypt, Arab Rep. in 1991 to that in 1999?
Your answer should be very brief. 0.38. What is the ratio of the Gross enrolment ratio (%) of Tajikistan in 1991 to that in 1999?
Give a very brief answer. 1.27. What is the difference between the highest and the second highest Gross enrolment ratio (%) in Fragile and conflict affected situations?
Offer a very short reply. 1.38. What is the difference between the highest and the second highest Gross enrolment ratio (%) in World?
Your answer should be compact. 4.49. What is the difference between the highest and the second highest Gross enrolment ratio (%) in Egypt, Arab Rep.?
Keep it short and to the point. 14.36. What is the difference between the highest and the second highest Gross enrolment ratio (%) of Tajikistan?
Give a very brief answer. 0.11. What is the difference between the highest and the lowest Gross enrolment ratio (%) in Fragile and conflict affected situations?
Give a very brief answer. 1.85. What is the difference between the highest and the lowest Gross enrolment ratio (%) in World?
Your response must be concise. 5.07. What is the difference between the highest and the lowest Gross enrolment ratio (%) in Egypt, Arab Rep.?
Provide a short and direct response. 19.9. What is the difference between the highest and the lowest Gross enrolment ratio (%) of Tajikistan?
Give a very brief answer. 4.72. 